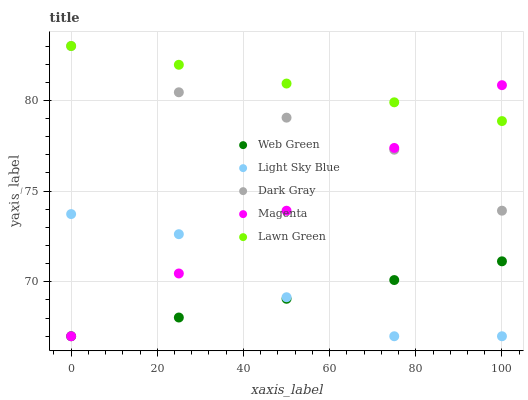Does Web Green have the minimum area under the curve?
Answer yes or no. Yes. Does Lawn Green have the maximum area under the curve?
Answer yes or no. Yes. Does Magenta have the minimum area under the curve?
Answer yes or no. No. Does Magenta have the maximum area under the curve?
Answer yes or no. No. Is Lawn Green the smoothest?
Answer yes or no. Yes. Is Light Sky Blue the roughest?
Answer yes or no. Yes. Is Magenta the smoothest?
Answer yes or no. No. Is Magenta the roughest?
Answer yes or no. No. Does Magenta have the lowest value?
Answer yes or no. Yes. Does Lawn Green have the lowest value?
Answer yes or no. No. Does Lawn Green have the highest value?
Answer yes or no. Yes. Does Magenta have the highest value?
Answer yes or no. No. Is Web Green less than Lawn Green?
Answer yes or no. Yes. Is Lawn Green greater than Web Green?
Answer yes or no. Yes. Does Lawn Green intersect Dark Gray?
Answer yes or no. Yes. Is Lawn Green less than Dark Gray?
Answer yes or no. No. Is Lawn Green greater than Dark Gray?
Answer yes or no. No. Does Web Green intersect Lawn Green?
Answer yes or no. No. 